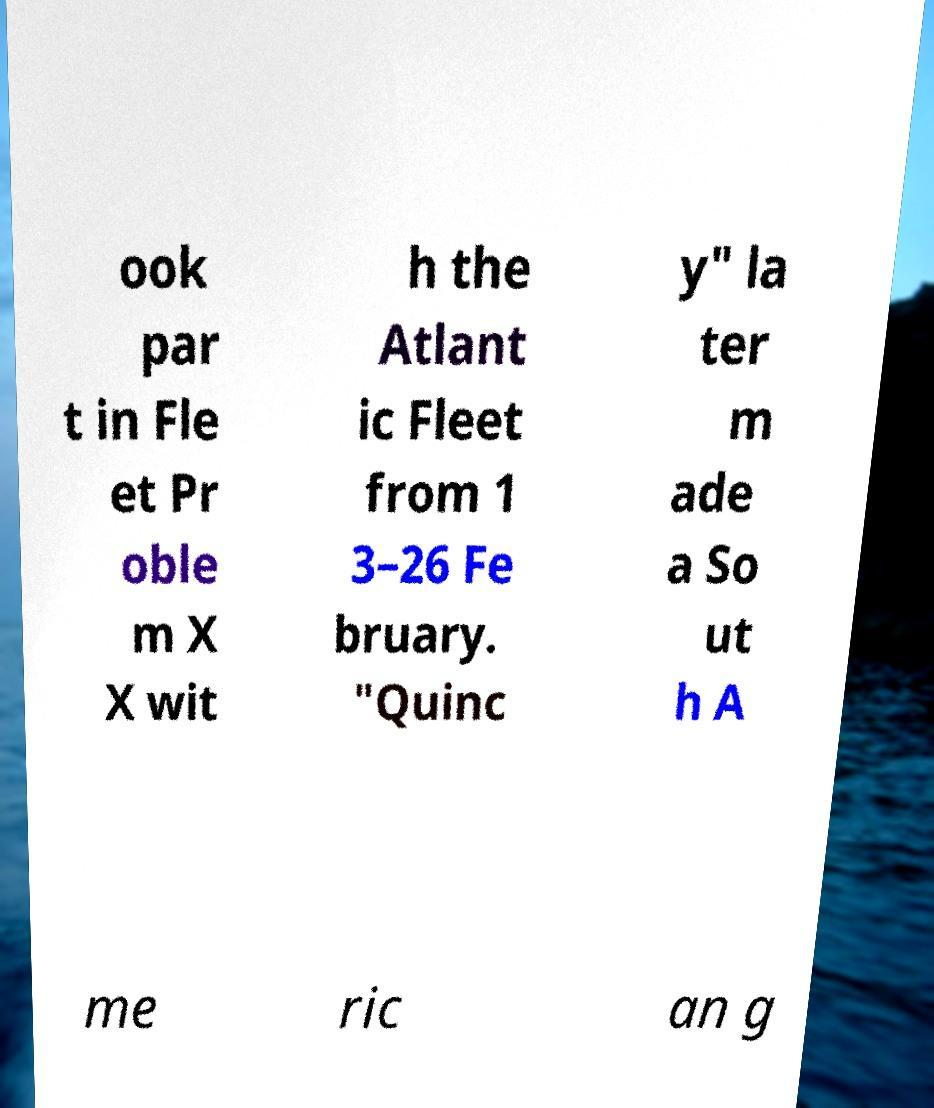I need the written content from this picture converted into text. Can you do that? ook par t in Fle et Pr oble m X X wit h the Atlant ic Fleet from 1 3–26 Fe bruary. "Quinc y" la ter m ade a So ut h A me ric an g 